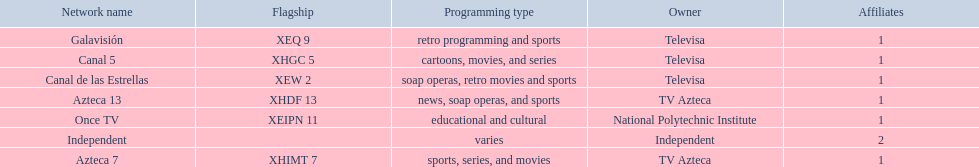How many networks does tv azteca own? 2. 